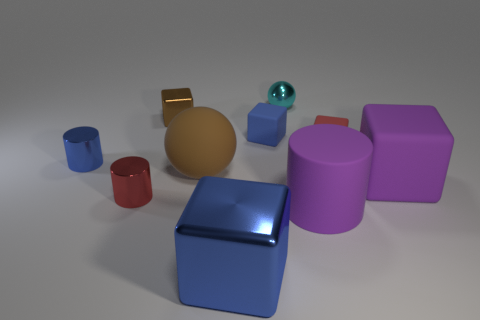Subtract all tiny shiny cylinders. How many cylinders are left? 1 Subtract all gray balls. How many blue cubes are left? 2 Subtract 1 cubes. How many cubes are left? 4 Subtract all brown spheres. How many spheres are left? 1 Subtract all balls. How many objects are left? 8 Add 1 tiny blue metallic cylinders. How many tiny blue metallic cylinders exist? 2 Subtract 1 red cylinders. How many objects are left? 9 Subtract all green spheres. Subtract all cyan cylinders. How many spheres are left? 2 Subtract all purple blocks. Subtract all red cylinders. How many objects are left? 8 Add 2 blue shiny cylinders. How many blue shiny cylinders are left? 3 